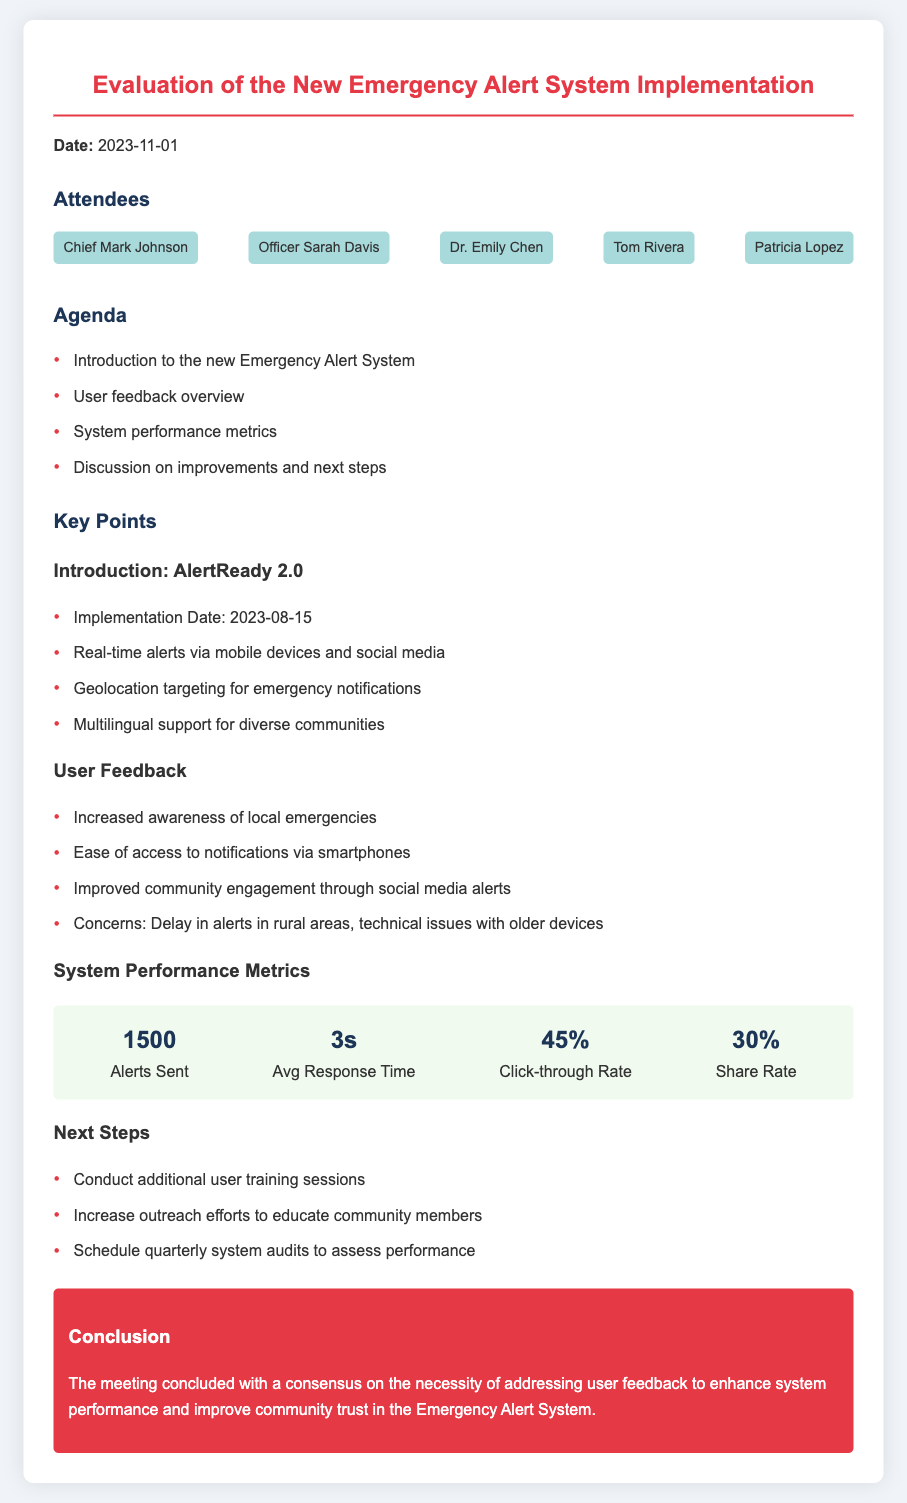What is the implementation date of the AlertReady 2.0? The implementation date is stated directly in the document under the introduction section.
Answer: 2023-08-15 How many alerts were sent out? The number of alerts sent is a specific metric provided in the system performance section.
Answer: 1500 What is the average response time for the alerts? The average response time is also a metric listed in the performance metrics of the document.
Answer: 3s What percentage represents the click-through rate? The click-through rate is provided among the performance metrics and indicates user engagement.
Answer: 45% What are the main concerns from user feedback? The document outlines the concerns listed under the user feedback section, needing synthesis from multiple points.
Answer: Delay in alerts in rural areas, technical issues with older devices Who chaired the meeting? The name of the person presiding over the meeting is mentioned in the attendees section.
Answer: Chief Mark Johnson What is one of the next steps mentioned? The next steps are suggested actions listed in the respective section, requiring selection from multiple options.
Answer: Conduct additional user training sessions What is the share rate of the alerts? The share rate is provided in the metrics and indicates how often users share the alerts on social platforms.
Answer: 30% 